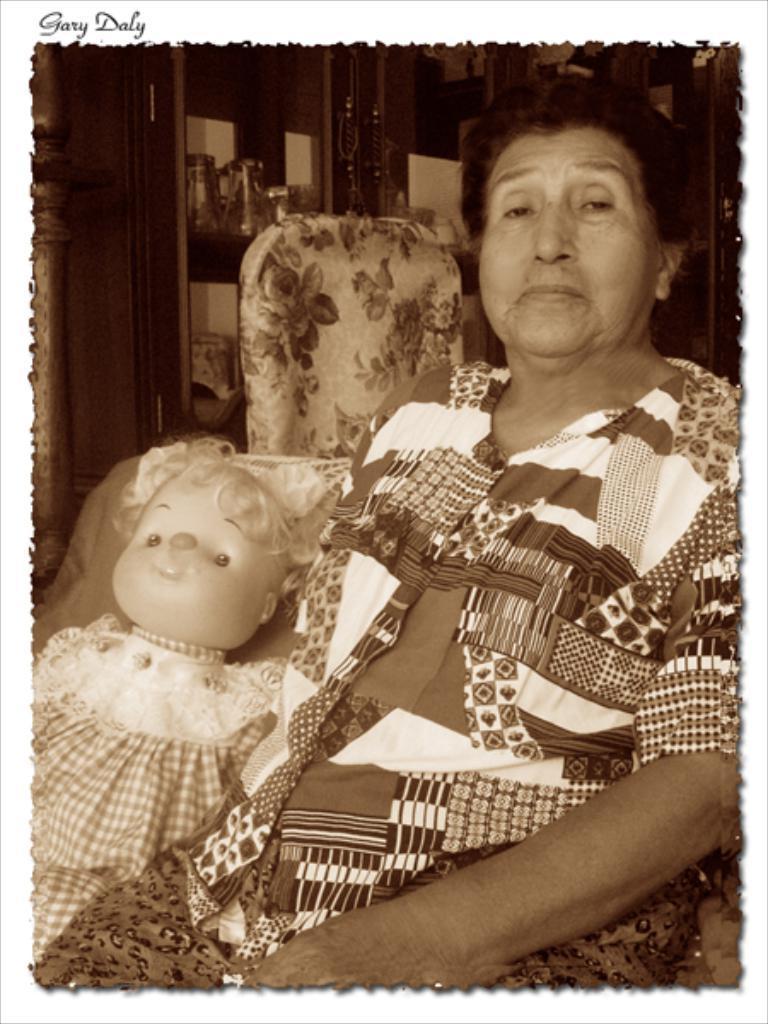Could you give a brief overview of what you see in this image? In this image I can see the person sitting and wearing the dress. To the side of the person I can see the toy. In the background I can see the cupboard. I can see the glasses inside the cupboard. 